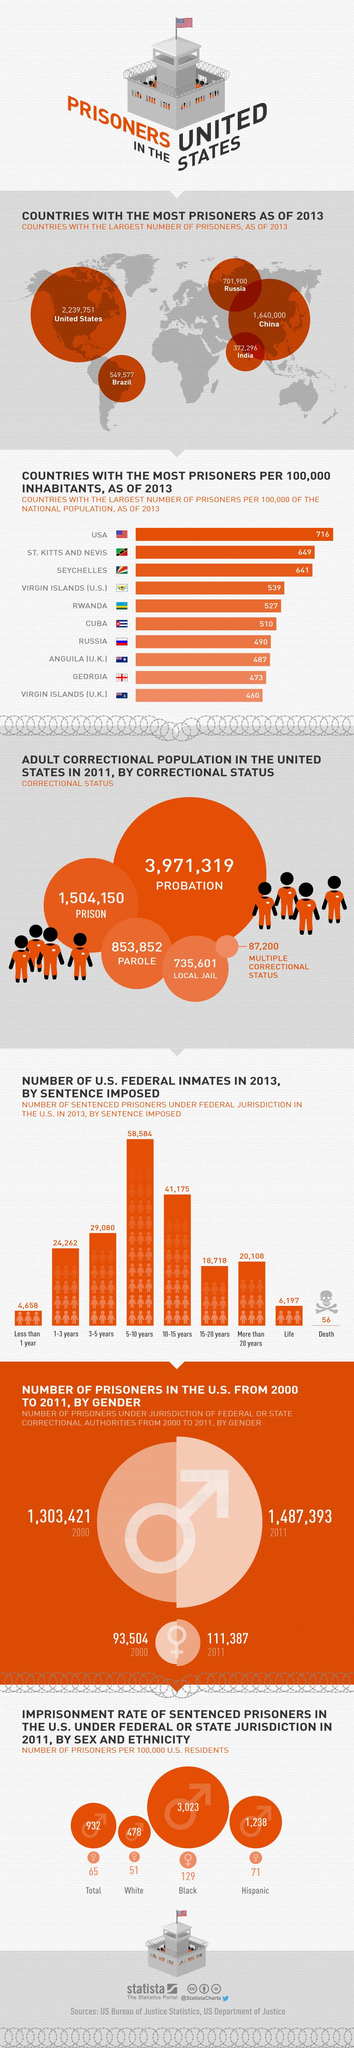Point out several critical features in this image. As of the year 2000, there were a total of 1,303,421 male prisoners under federal jurisdiction in the United States. In 2013, there were 56 prisoners under federal jurisdiction who had imposed a death sentence. In 2011, a total of 853,852 prisoners in the U.S. prison system were granted parole, as reported by their correctional status. In 2011, the imprisonment rate of Hispanic female prisoners in the United States, under either federal or state jurisdiction, was 71%. In 2013, a total of 6,197 prisoners in federal jurisdiction were sentenced to life imprisonment. 